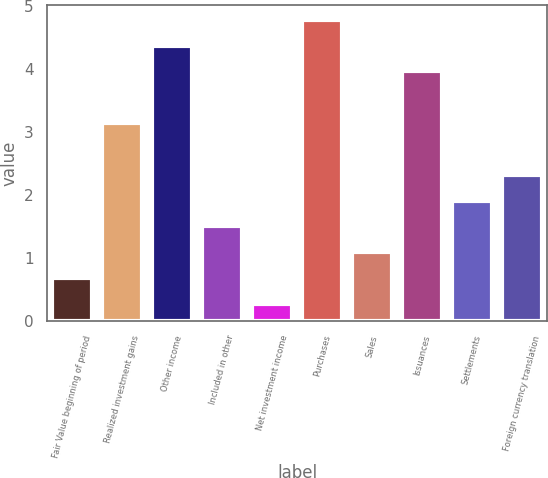<chart> <loc_0><loc_0><loc_500><loc_500><bar_chart><fcel>Fair Value beginning of period<fcel>Realized investment gains<fcel>Other income<fcel>Included in other<fcel>Net investment income<fcel>Purchases<fcel>Sales<fcel>Issuances<fcel>Settlements<fcel>Foreign currency translation<nl><fcel>0.68<fcel>3.14<fcel>4.37<fcel>1.5<fcel>0.27<fcel>4.78<fcel>1.09<fcel>3.96<fcel>1.91<fcel>2.32<nl></chart> 